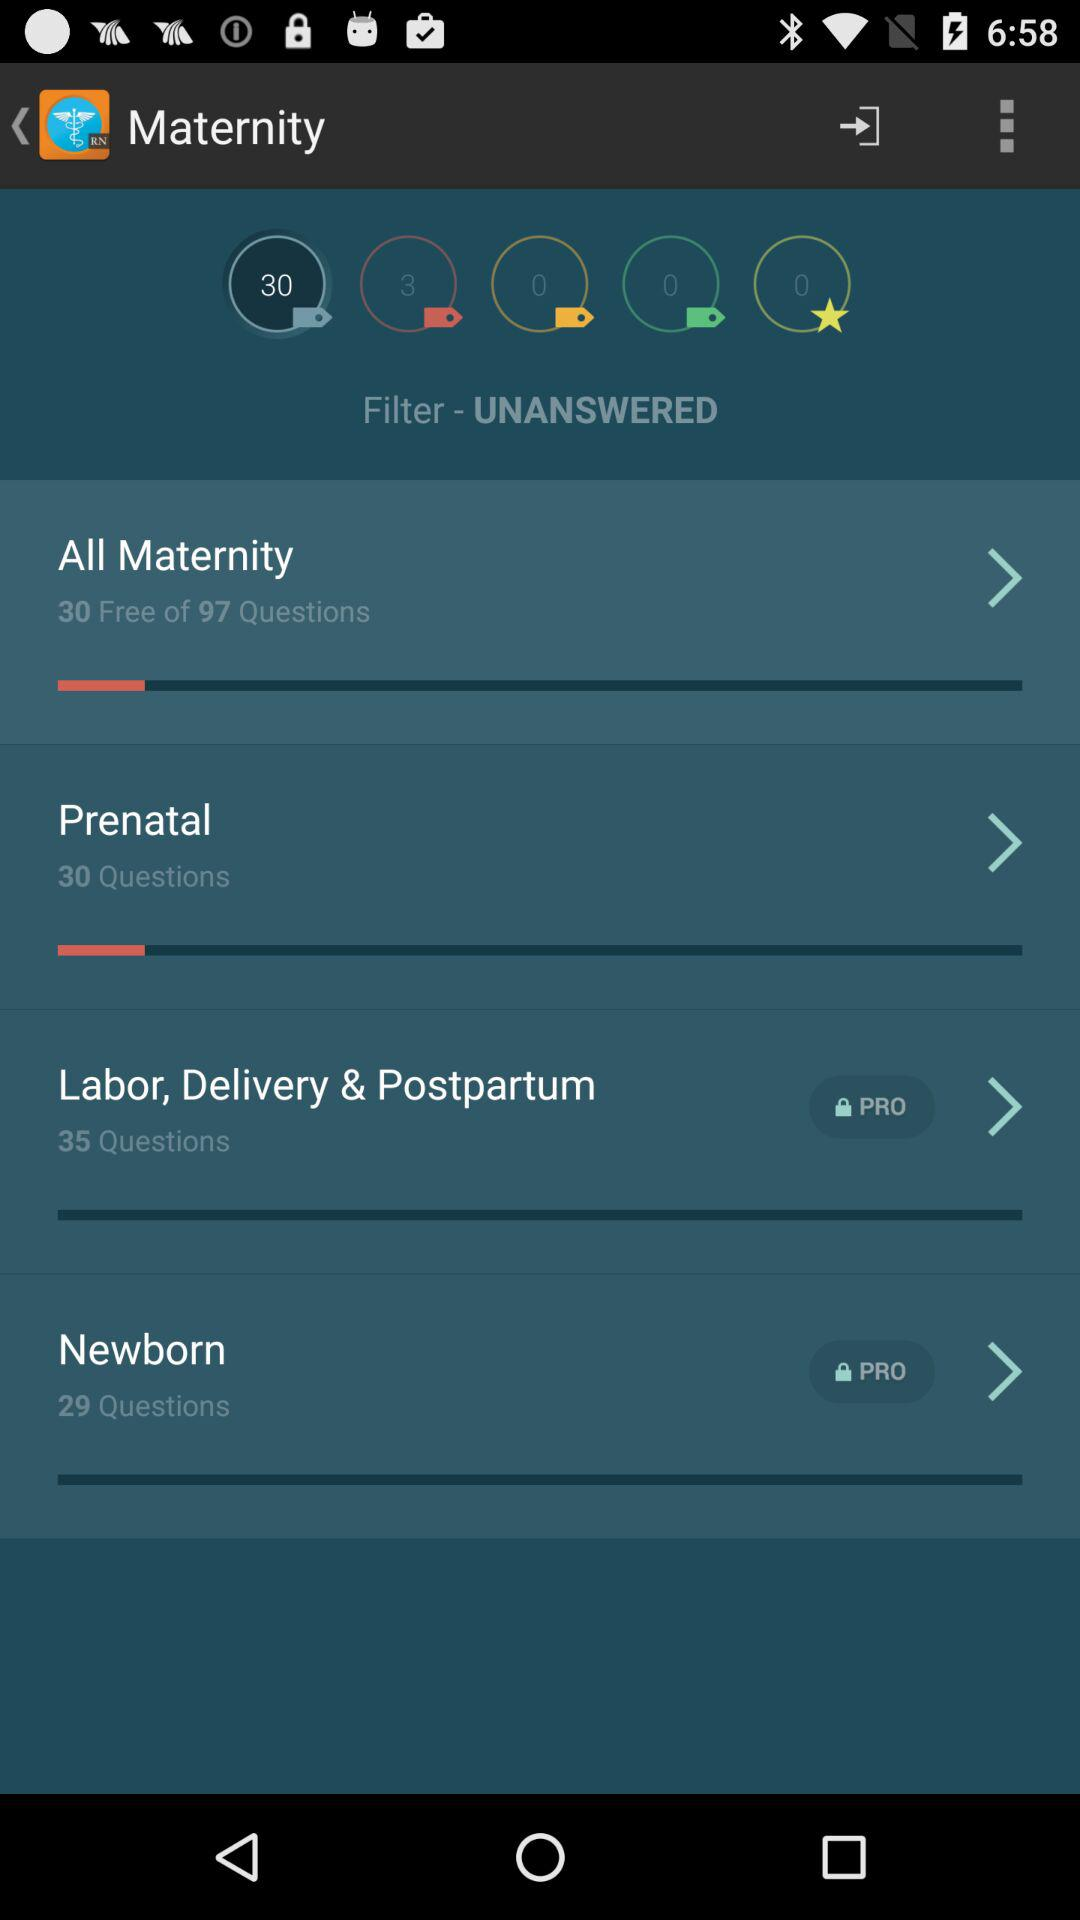What are the different maternity question sections there? The different maternity question sections are "All Maternity", "Prenatal", "Labor, Delivery & Postpartum" and "Newborn". 